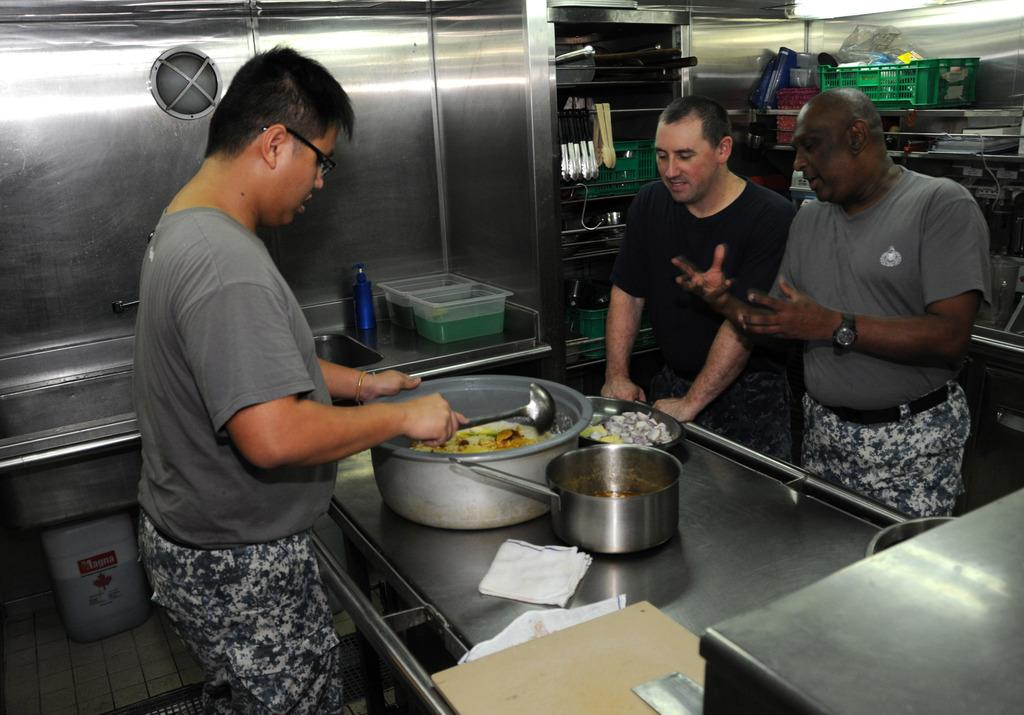How many people are present in the image? There are 3 people in the image. What are the people doing in the image? The people are making food. Are the people interacting with each other in the image? Yes, two people are talking to each other. What objects can be seen in the background of the image? There are spoons, a basket, and a cloth in the background. What type of yam is being used to make the food in the image? There is no yam present in the image, and therefore no specific type of yam can be identified. Can you see a fireman in the image? No, there is no fireman present in the image. 